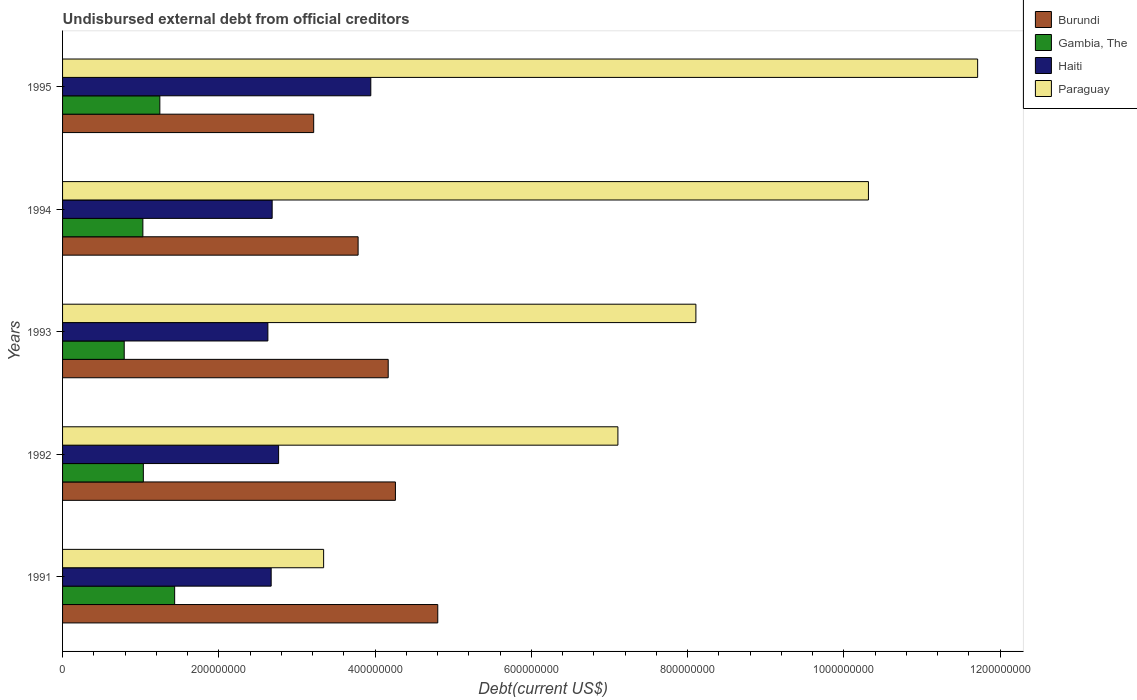How many different coloured bars are there?
Offer a very short reply. 4. Are the number of bars on each tick of the Y-axis equal?
Ensure brevity in your answer.  Yes. What is the label of the 2nd group of bars from the top?
Offer a terse response. 1994. What is the total debt in Gambia, The in 1991?
Provide a succinct answer. 1.43e+08. Across all years, what is the maximum total debt in Burundi?
Keep it short and to the point. 4.80e+08. Across all years, what is the minimum total debt in Gambia, The?
Your answer should be compact. 7.89e+07. What is the total total debt in Paraguay in the graph?
Give a very brief answer. 4.06e+09. What is the difference between the total debt in Haiti in 1991 and that in 1993?
Make the answer very short. 4.21e+06. What is the difference between the total debt in Paraguay in 1993 and the total debt in Burundi in 1994?
Offer a terse response. 4.32e+08. What is the average total debt in Paraguay per year?
Provide a short and direct response. 8.12e+08. In the year 1991, what is the difference between the total debt in Paraguay and total debt in Haiti?
Give a very brief answer. 6.71e+07. In how many years, is the total debt in Burundi greater than 720000000 US$?
Provide a short and direct response. 0. What is the ratio of the total debt in Burundi in 1991 to that in 1992?
Your answer should be compact. 1.13. Is the difference between the total debt in Paraguay in 1993 and 1995 greater than the difference between the total debt in Haiti in 1993 and 1995?
Make the answer very short. No. What is the difference between the highest and the second highest total debt in Paraguay?
Offer a terse response. 1.40e+08. What is the difference between the highest and the lowest total debt in Gambia, The?
Your answer should be compact. 6.46e+07. Is the sum of the total debt in Paraguay in 1991 and 1993 greater than the maximum total debt in Gambia, The across all years?
Offer a very short reply. Yes. What does the 3rd bar from the top in 1992 represents?
Provide a succinct answer. Gambia, The. What does the 4th bar from the bottom in 1991 represents?
Give a very brief answer. Paraguay. Is it the case that in every year, the sum of the total debt in Haiti and total debt in Paraguay is greater than the total debt in Gambia, The?
Provide a succinct answer. Yes. Are the values on the major ticks of X-axis written in scientific E-notation?
Offer a very short reply. No. Does the graph contain any zero values?
Your response must be concise. No. Where does the legend appear in the graph?
Your answer should be very brief. Top right. How are the legend labels stacked?
Provide a succinct answer. Vertical. What is the title of the graph?
Your answer should be very brief. Undisbursed external debt from official creditors. What is the label or title of the X-axis?
Your answer should be very brief. Debt(current US$). What is the label or title of the Y-axis?
Ensure brevity in your answer.  Years. What is the Debt(current US$) in Burundi in 1991?
Give a very brief answer. 4.80e+08. What is the Debt(current US$) of Gambia, The in 1991?
Keep it short and to the point. 1.43e+08. What is the Debt(current US$) in Haiti in 1991?
Offer a very short reply. 2.67e+08. What is the Debt(current US$) in Paraguay in 1991?
Keep it short and to the point. 3.34e+08. What is the Debt(current US$) in Burundi in 1992?
Your answer should be very brief. 4.26e+08. What is the Debt(current US$) of Gambia, The in 1992?
Provide a succinct answer. 1.03e+08. What is the Debt(current US$) in Haiti in 1992?
Your response must be concise. 2.76e+08. What is the Debt(current US$) of Paraguay in 1992?
Keep it short and to the point. 7.11e+08. What is the Debt(current US$) in Burundi in 1993?
Ensure brevity in your answer.  4.17e+08. What is the Debt(current US$) of Gambia, The in 1993?
Ensure brevity in your answer.  7.89e+07. What is the Debt(current US$) in Haiti in 1993?
Keep it short and to the point. 2.63e+08. What is the Debt(current US$) of Paraguay in 1993?
Your answer should be very brief. 8.11e+08. What is the Debt(current US$) in Burundi in 1994?
Offer a very short reply. 3.78e+08. What is the Debt(current US$) in Gambia, The in 1994?
Make the answer very short. 1.03e+08. What is the Debt(current US$) in Haiti in 1994?
Offer a very short reply. 2.68e+08. What is the Debt(current US$) in Paraguay in 1994?
Your answer should be very brief. 1.03e+09. What is the Debt(current US$) of Burundi in 1995?
Offer a terse response. 3.21e+08. What is the Debt(current US$) in Gambia, The in 1995?
Make the answer very short. 1.24e+08. What is the Debt(current US$) of Haiti in 1995?
Your answer should be very brief. 3.94e+08. What is the Debt(current US$) in Paraguay in 1995?
Offer a very short reply. 1.17e+09. Across all years, what is the maximum Debt(current US$) in Burundi?
Ensure brevity in your answer.  4.80e+08. Across all years, what is the maximum Debt(current US$) of Gambia, The?
Offer a terse response. 1.43e+08. Across all years, what is the maximum Debt(current US$) in Haiti?
Offer a very short reply. 3.94e+08. Across all years, what is the maximum Debt(current US$) in Paraguay?
Your response must be concise. 1.17e+09. Across all years, what is the minimum Debt(current US$) of Burundi?
Give a very brief answer. 3.21e+08. Across all years, what is the minimum Debt(current US$) in Gambia, The?
Provide a short and direct response. 7.89e+07. Across all years, what is the minimum Debt(current US$) of Haiti?
Your response must be concise. 2.63e+08. Across all years, what is the minimum Debt(current US$) of Paraguay?
Provide a short and direct response. 3.34e+08. What is the total Debt(current US$) in Burundi in the graph?
Provide a short and direct response. 2.02e+09. What is the total Debt(current US$) of Gambia, The in the graph?
Provide a succinct answer. 5.53e+08. What is the total Debt(current US$) in Haiti in the graph?
Your answer should be very brief. 1.47e+09. What is the total Debt(current US$) of Paraguay in the graph?
Provide a succinct answer. 4.06e+09. What is the difference between the Debt(current US$) in Burundi in 1991 and that in 1992?
Keep it short and to the point. 5.42e+07. What is the difference between the Debt(current US$) in Gambia, The in 1991 and that in 1992?
Your answer should be compact. 4.01e+07. What is the difference between the Debt(current US$) of Haiti in 1991 and that in 1992?
Provide a succinct answer. -9.52e+06. What is the difference between the Debt(current US$) of Paraguay in 1991 and that in 1992?
Provide a short and direct response. -3.77e+08. What is the difference between the Debt(current US$) of Burundi in 1991 and that in 1993?
Offer a very short reply. 6.34e+07. What is the difference between the Debt(current US$) of Gambia, The in 1991 and that in 1993?
Your answer should be very brief. 6.46e+07. What is the difference between the Debt(current US$) in Haiti in 1991 and that in 1993?
Your response must be concise. 4.21e+06. What is the difference between the Debt(current US$) in Paraguay in 1991 and that in 1993?
Keep it short and to the point. -4.76e+08. What is the difference between the Debt(current US$) of Burundi in 1991 and that in 1994?
Keep it short and to the point. 1.02e+08. What is the difference between the Debt(current US$) in Gambia, The in 1991 and that in 1994?
Your response must be concise. 4.07e+07. What is the difference between the Debt(current US$) in Haiti in 1991 and that in 1994?
Offer a very short reply. -1.28e+06. What is the difference between the Debt(current US$) of Paraguay in 1991 and that in 1994?
Offer a terse response. -6.97e+08. What is the difference between the Debt(current US$) in Burundi in 1991 and that in 1995?
Keep it short and to the point. 1.59e+08. What is the difference between the Debt(current US$) in Gambia, The in 1991 and that in 1995?
Keep it short and to the point. 1.90e+07. What is the difference between the Debt(current US$) of Haiti in 1991 and that in 1995?
Give a very brief answer. -1.28e+08. What is the difference between the Debt(current US$) of Paraguay in 1991 and that in 1995?
Your answer should be very brief. -8.37e+08. What is the difference between the Debt(current US$) of Burundi in 1992 and that in 1993?
Give a very brief answer. 9.24e+06. What is the difference between the Debt(current US$) of Gambia, The in 1992 and that in 1993?
Offer a terse response. 2.45e+07. What is the difference between the Debt(current US$) in Haiti in 1992 and that in 1993?
Your answer should be very brief. 1.37e+07. What is the difference between the Debt(current US$) of Paraguay in 1992 and that in 1993?
Offer a very short reply. -9.98e+07. What is the difference between the Debt(current US$) of Burundi in 1992 and that in 1994?
Give a very brief answer. 4.78e+07. What is the difference between the Debt(current US$) in Gambia, The in 1992 and that in 1994?
Offer a very short reply. 5.95e+05. What is the difference between the Debt(current US$) in Haiti in 1992 and that in 1994?
Provide a succinct answer. 8.25e+06. What is the difference between the Debt(current US$) in Paraguay in 1992 and that in 1994?
Your response must be concise. -3.21e+08. What is the difference between the Debt(current US$) of Burundi in 1992 and that in 1995?
Provide a short and direct response. 1.05e+08. What is the difference between the Debt(current US$) in Gambia, The in 1992 and that in 1995?
Keep it short and to the point. -2.11e+07. What is the difference between the Debt(current US$) in Haiti in 1992 and that in 1995?
Provide a succinct answer. -1.18e+08. What is the difference between the Debt(current US$) of Paraguay in 1992 and that in 1995?
Make the answer very short. -4.60e+08. What is the difference between the Debt(current US$) of Burundi in 1993 and that in 1994?
Make the answer very short. 3.85e+07. What is the difference between the Debt(current US$) of Gambia, The in 1993 and that in 1994?
Ensure brevity in your answer.  -2.39e+07. What is the difference between the Debt(current US$) of Haiti in 1993 and that in 1994?
Offer a very short reply. -5.49e+06. What is the difference between the Debt(current US$) of Paraguay in 1993 and that in 1994?
Provide a succinct answer. -2.21e+08. What is the difference between the Debt(current US$) in Burundi in 1993 and that in 1995?
Make the answer very short. 9.54e+07. What is the difference between the Debt(current US$) of Gambia, The in 1993 and that in 1995?
Provide a short and direct response. -4.56e+07. What is the difference between the Debt(current US$) of Haiti in 1993 and that in 1995?
Provide a succinct answer. -1.32e+08. What is the difference between the Debt(current US$) of Paraguay in 1993 and that in 1995?
Your response must be concise. -3.61e+08. What is the difference between the Debt(current US$) in Burundi in 1994 and that in 1995?
Provide a short and direct response. 5.68e+07. What is the difference between the Debt(current US$) in Gambia, The in 1994 and that in 1995?
Ensure brevity in your answer.  -2.17e+07. What is the difference between the Debt(current US$) in Haiti in 1994 and that in 1995?
Your answer should be compact. -1.26e+08. What is the difference between the Debt(current US$) of Paraguay in 1994 and that in 1995?
Make the answer very short. -1.40e+08. What is the difference between the Debt(current US$) in Burundi in 1991 and the Debt(current US$) in Gambia, The in 1992?
Your response must be concise. 3.77e+08. What is the difference between the Debt(current US$) of Burundi in 1991 and the Debt(current US$) of Haiti in 1992?
Your response must be concise. 2.04e+08. What is the difference between the Debt(current US$) in Burundi in 1991 and the Debt(current US$) in Paraguay in 1992?
Provide a short and direct response. -2.31e+08. What is the difference between the Debt(current US$) in Gambia, The in 1991 and the Debt(current US$) in Haiti in 1992?
Make the answer very short. -1.33e+08. What is the difference between the Debt(current US$) of Gambia, The in 1991 and the Debt(current US$) of Paraguay in 1992?
Your answer should be very brief. -5.67e+08. What is the difference between the Debt(current US$) of Haiti in 1991 and the Debt(current US$) of Paraguay in 1992?
Make the answer very short. -4.44e+08. What is the difference between the Debt(current US$) of Burundi in 1991 and the Debt(current US$) of Gambia, The in 1993?
Provide a short and direct response. 4.01e+08. What is the difference between the Debt(current US$) in Burundi in 1991 and the Debt(current US$) in Haiti in 1993?
Keep it short and to the point. 2.17e+08. What is the difference between the Debt(current US$) of Burundi in 1991 and the Debt(current US$) of Paraguay in 1993?
Make the answer very short. -3.30e+08. What is the difference between the Debt(current US$) in Gambia, The in 1991 and the Debt(current US$) in Haiti in 1993?
Your answer should be compact. -1.19e+08. What is the difference between the Debt(current US$) in Gambia, The in 1991 and the Debt(current US$) in Paraguay in 1993?
Your answer should be compact. -6.67e+08. What is the difference between the Debt(current US$) of Haiti in 1991 and the Debt(current US$) of Paraguay in 1993?
Provide a succinct answer. -5.44e+08. What is the difference between the Debt(current US$) of Burundi in 1991 and the Debt(current US$) of Gambia, The in 1994?
Make the answer very short. 3.77e+08. What is the difference between the Debt(current US$) in Burundi in 1991 and the Debt(current US$) in Haiti in 1994?
Your answer should be very brief. 2.12e+08. What is the difference between the Debt(current US$) of Burundi in 1991 and the Debt(current US$) of Paraguay in 1994?
Ensure brevity in your answer.  -5.51e+08. What is the difference between the Debt(current US$) of Gambia, The in 1991 and the Debt(current US$) of Haiti in 1994?
Make the answer very short. -1.25e+08. What is the difference between the Debt(current US$) in Gambia, The in 1991 and the Debt(current US$) in Paraguay in 1994?
Provide a short and direct response. -8.88e+08. What is the difference between the Debt(current US$) in Haiti in 1991 and the Debt(current US$) in Paraguay in 1994?
Your answer should be compact. -7.64e+08. What is the difference between the Debt(current US$) of Burundi in 1991 and the Debt(current US$) of Gambia, The in 1995?
Make the answer very short. 3.56e+08. What is the difference between the Debt(current US$) in Burundi in 1991 and the Debt(current US$) in Haiti in 1995?
Give a very brief answer. 8.57e+07. What is the difference between the Debt(current US$) of Burundi in 1991 and the Debt(current US$) of Paraguay in 1995?
Provide a succinct answer. -6.91e+08. What is the difference between the Debt(current US$) of Gambia, The in 1991 and the Debt(current US$) of Haiti in 1995?
Make the answer very short. -2.51e+08. What is the difference between the Debt(current US$) in Gambia, The in 1991 and the Debt(current US$) in Paraguay in 1995?
Your response must be concise. -1.03e+09. What is the difference between the Debt(current US$) of Haiti in 1991 and the Debt(current US$) of Paraguay in 1995?
Provide a short and direct response. -9.04e+08. What is the difference between the Debt(current US$) in Burundi in 1992 and the Debt(current US$) in Gambia, The in 1993?
Provide a short and direct response. 3.47e+08. What is the difference between the Debt(current US$) in Burundi in 1992 and the Debt(current US$) in Haiti in 1993?
Make the answer very short. 1.63e+08. What is the difference between the Debt(current US$) in Burundi in 1992 and the Debt(current US$) in Paraguay in 1993?
Your response must be concise. -3.85e+08. What is the difference between the Debt(current US$) of Gambia, The in 1992 and the Debt(current US$) of Haiti in 1993?
Provide a short and direct response. -1.59e+08. What is the difference between the Debt(current US$) of Gambia, The in 1992 and the Debt(current US$) of Paraguay in 1993?
Offer a very short reply. -7.07e+08. What is the difference between the Debt(current US$) of Haiti in 1992 and the Debt(current US$) of Paraguay in 1993?
Ensure brevity in your answer.  -5.34e+08. What is the difference between the Debt(current US$) of Burundi in 1992 and the Debt(current US$) of Gambia, The in 1994?
Make the answer very short. 3.23e+08. What is the difference between the Debt(current US$) of Burundi in 1992 and the Debt(current US$) of Haiti in 1994?
Your answer should be very brief. 1.58e+08. What is the difference between the Debt(current US$) of Burundi in 1992 and the Debt(current US$) of Paraguay in 1994?
Your answer should be compact. -6.05e+08. What is the difference between the Debt(current US$) in Gambia, The in 1992 and the Debt(current US$) in Haiti in 1994?
Ensure brevity in your answer.  -1.65e+08. What is the difference between the Debt(current US$) of Gambia, The in 1992 and the Debt(current US$) of Paraguay in 1994?
Your answer should be compact. -9.28e+08. What is the difference between the Debt(current US$) in Haiti in 1992 and the Debt(current US$) in Paraguay in 1994?
Make the answer very short. -7.55e+08. What is the difference between the Debt(current US$) of Burundi in 1992 and the Debt(current US$) of Gambia, The in 1995?
Your answer should be very brief. 3.02e+08. What is the difference between the Debt(current US$) in Burundi in 1992 and the Debt(current US$) in Haiti in 1995?
Offer a terse response. 3.15e+07. What is the difference between the Debt(current US$) in Burundi in 1992 and the Debt(current US$) in Paraguay in 1995?
Keep it short and to the point. -7.45e+08. What is the difference between the Debt(current US$) of Gambia, The in 1992 and the Debt(current US$) of Haiti in 1995?
Offer a terse response. -2.91e+08. What is the difference between the Debt(current US$) in Gambia, The in 1992 and the Debt(current US$) in Paraguay in 1995?
Offer a very short reply. -1.07e+09. What is the difference between the Debt(current US$) of Haiti in 1992 and the Debt(current US$) of Paraguay in 1995?
Keep it short and to the point. -8.95e+08. What is the difference between the Debt(current US$) in Burundi in 1993 and the Debt(current US$) in Gambia, The in 1994?
Keep it short and to the point. 3.14e+08. What is the difference between the Debt(current US$) of Burundi in 1993 and the Debt(current US$) of Haiti in 1994?
Provide a succinct answer. 1.49e+08. What is the difference between the Debt(current US$) in Burundi in 1993 and the Debt(current US$) in Paraguay in 1994?
Ensure brevity in your answer.  -6.15e+08. What is the difference between the Debt(current US$) in Gambia, The in 1993 and the Debt(current US$) in Haiti in 1994?
Ensure brevity in your answer.  -1.89e+08. What is the difference between the Debt(current US$) of Gambia, The in 1993 and the Debt(current US$) of Paraguay in 1994?
Offer a terse response. -9.52e+08. What is the difference between the Debt(current US$) of Haiti in 1993 and the Debt(current US$) of Paraguay in 1994?
Offer a very short reply. -7.69e+08. What is the difference between the Debt(current US$) of Burundi in 1993 and the Debt(current US$) of Gambia, The in 1995?
Your answer should be compact. 2.92e+08. What is the difference between the Debt(current US$) of Burundi in 1993 and the Debt(current US$) of Haiti in 1995?
Make the answer very short. 2.23e+07. What is the difference between the Debt(current US$) of Burundi in 1993 and the Debt(current US$) of Paraguay in 1995?
Ensure brevity in your answer.  -7.54e+08. What is the difference between the Debt(current US$) of Gambia, The in 1993 and the Debt(current US$) of Haiti in 1995?
Ensure brevity in your answer.  -3.16e+08. What is the difference between the Debt(current US$) in Gambia, The in 1993 and the Debt(current US$) in Paraguay in 1995?
Your answer should be compact. -1.09e+09. What is the difference between the Debt(current US$) in Haiti in 1993 and the Debt(current US$) in Paraguay in 1995?
Provide a short and direct response. -9.08e+08. What is the difference between the Debt(current US$) in Burundi in 1994 and the Debt(current US$) in Gambia, The in 1995?
Offer a terse response. 2.54e+08. What is the difference between the Debt(current US$) in Burundi in 1994 and the Debt(current US$) in Haiti in 1995?
Offer a terse response. -1.62e+07. What is the difference between the Debt(current US$) in Burundi in 1994 and the Debt(current US$) in Paraguay in 1995?
Make the answer very short. -7.93e+08. What is the difference between the Debt(current US$) in Gambia, The in 1994 and the Debt(current US$) in Haiti in 1995?
Offer a very short reply. -2.92e+08. What is the difference between the Debt(current US$) in Gambia, The in 1994 and the Debt(current US$) in Paraguay in 1995?
Offer a very short reply. -1.07e+09. What is the difference between the Debt(current US$) of Haiti in 1994 and the Debt(current US$) of Paraguay in 1995?
Give a very brief answer. -9.03e+08. What is the average Debt(current US$) in Burundi per year?
Your answer should be very brief. 4.05e+08. What is the average Debt(current US$) in Gambia, The per year?
Give a very brief answer. 1.11e+08. What is the average Debt(current US$) of Haiti per year?
Keep it short and to the point. 2.94e+08. What is the average Debt(current US$) of Paraguay per year?
Your response must be concise. 8.12e+08. In the year 1991, what is the difference between the Debt(current US$) of Burundi and Debt(current US$) of Gambia, The?
Provide a short and direct response. 3.37e+08. In the year 1991, what is the difference between the Debt(current US$) in Burundi and Debt(current US$) in Haiti?
Offer a terse response. 2.13e+08. In the year 1991, what is the difference between the Debt(current US$) in Burundi and Debt(current US$) in Paraguay?
Your answer should be very brief. 1.46e+08. In the year 1991, what is the difference between the Debt(current US$) of Gambia, The and Debt(current US$) of Haiti?
Provide a short and direct response. -1.24e+08. In the year 1991, what is the difference between the Debt(current US$) in Gambia, The and Debt(current US$) in Paraguay?
Keep it short and to the point. -1.91e+08. In the year 1991, what is the difference between the Debt(current US$) of Haiti and Debt(current US$) of Paraguay?
Keep it short and to the point. -6.71e+07. In the year 1992, what is the difference between the Debt(current US$) in Burundi and Debt(current US$) in Gambia, The?
Provide a short and direct response. 3.23e+08. In the year 1992, what is the difference between the Debt(current US$) in Burundi and Debt(current US$) in Haiti?
Provide a short and direct response. 1.50e+08. In the year 1992, what is the difference between the Debt(current US$) in Burundi and Debt(current US$) in Paraguay?
Your response must be concise. -2.85e+08. In the year 1992, what is the difference between the Debt(current US$) in Gambia, The and Debt(current US$) in Haiti?
Offer a very short reply. -1.73e+08. In the year 1992, what is the difference between the Debt(current US$) of Gambia, The and Debt(current US$) of Paraguay?
Ensure brevity in your answer.  -6.07e+08. In the year 1992, what is the difference between the Debt(current US$) in Haiti and Debt(current US$) in Paraguay?
Offer a very short reply. -4.34e+08. In the year 1993, what is the difference between the Debt(current US$) in Burundi and Debt(current US$) in Gambia, The?
Your answer should be compact. 3.38e+08. In the year 1993, what is the difference between the Debt(current US$) in Burundi and Debt(current US$) in Haiti?
Give a very brief answer. 1.54e+08. In the year 1993, what is the difference between the Debt(current US$) of Burundi and Debt(current US$) of Paraguay?
Provide a succinct answer. -3.94e+08. In the year 1993, what is the difference between the Debt(current US$) of Gambia, The and Debt(current US$) of Haiti?
Provide a short and direct response. -1.84e+08. In the year 1993, what is the difference between the Debt(current US$) in Gambia, The and Debt(current US$) in Paraguay?
Keep it short and to the point. -7.32e+08. In the year 1993, what is the difference between the Debt(current US$) of Haiti and Debt(current US$) of Paraguay?
Make the answer very short. -5.48e+08. In the year 1994, what is the difference between the Debt(current US$) of Burundi and Debt(current US$) of Gambia, The?
Ensure brevity in your answer.  2.75e+08. In the year 1994, what is the difference between the Debt(current US$) in Burundi and Debt(current US$) in Haiti?
Keep it short and to the point. 1.10e+08. In the year 1994, what is the difference between the Debt(current US$) in Burundi and Debt(current US$) in Paraguay?
Provide a succinct answer. -6.53e+08. In the year 1994, what is the difference between the Debt(current US$) of Gambia, The and Debt(current US$) of Haiti?
Keep it short and to the point. -1.65e+08. In the year 1994, what is the difference between the Debt(current US$) in Gambia, The and Debt(current US$) in Paraguay?
Your answer should be very brief. -9.29e+08. In the year 1994, what is the difference between the Debt(current US$) of Haiti and Debt(current US$) of Paraguay?
Your response must be concise. -7.63e+08. In the year 1995, what is the difference between the Debt(current US$) of Burundi and Debt(current US$) of Gambia, The?
Ensure brevity in your answer.  1.97e+08. In the year 1995, what is the difference between the Debt(current US$) of Burundi and Debt(current US$) of Haiti?
Provide a succinct answer. -7.31e+07. In the year 1995, what is the difference between the Debt(current US$) in Burundi and Debt(current US$) in Paraguay?
Offer a terse response. -8.50e+08. In the year 1995, what is the difference between the Debt(current US$) of Gambia, The and Debt(current US$) of Haiti?
Ensure brevity in your answer.  -2.70e+08. In the year 1995, what is the difference between the Debt(current US$) of Gambia, The and Debt(current US$) of Paraguay?
Your response must be concise. -1.05e+09. In the year 1995, what is the difference between the Debt(current US$) of Haiti and Debt(current US$) of Paraguay?
Your response must be concise. -7.77e+08. What is the ratio of the Debt(current US$) in Burundi in 1991 to that in 1992?
Provide a short and direct response. 1.13. What is the ratio of the Debt(current US$) of Gambia, The in 1991 to that in 1992?
Make the answer very short. 1.39. What is the ratio of the Debt(current US$) of Haiti in 1991 to that in 1992?
Ensure brevity in your answer.  0.97. What is the ratio of the Debt(current US$) of Paraguay in 1991 to that in 1992?
Your response must be concise. 0.47. What is the ratio of the Debt(current US$) in Burundi in 1991 to that in 1993?
Your answer should be very brief. 1.15. What is the ratio of the Debt(current US$) in Gambia, The in 1991 to that in 1993?
Provide a succinct answer. 1.82. What is the ratio of the Debt(current US$) in Paraguay in 1991 to that in 1993?
Provide a short and direct response. 0.41. What is the ratio of the Debt(current US$) of Burundi in 1991 to that in 1994?
Keep it short and to the point. 1.27. What is the ratio of the Debt(current US$) in Gambia, The in 1991 to that in 1994?
Keep it short and to the point. 1.4. What is the ratio of the Debt(current US$) of Haiti in 1991 to that in 1994?
Offer a very short reply. 1. What is the ratio of the Debt(current US$) of Paraguay in 1991 to that in 1994?
Offer a terse response. 0.32. What is the ratio of the Debt(current US$) of Burundi in 1991 to that in 1995?
Make the answer very short. 1.49. What is the ratio of the Debt(current US$) of Gambia, The in 1991 to that in 1995?
Give a very brief answer. 1.15. What is the ratio of the Debt(current US$) of Haiti in 1991 to that in 1995?
Provide a short and direct response. 0.68. What is the ratio of the Debt(current US$) of Paraguay in 1991 to that in 1995?
Provide a short and direct response. 0.29. What is the ratio of the Debt(current US$) in Burundi in 1992 to that in 1993?
Make the answer very short. 1.02. What is the ratio of the Debt(current US$) in Gambia, The in 1992 to that in 1993?
Provide a short and direct response. 1.31. What is the ratio of the Debt(current US$) of Haiti in 1992 to that in 1993?
Your answer should be compact. 1.05. What is the ratio of the Debt(current US$) in Paraguay in 1992 to that in 1993?
Your response must be concise. 0.88. What is the ratio of the Debt(current US$) in Burundi in 1992 to that in 1994?
Ensure brevity in your answer.  1.13. What is the ratio of the Debt(current US$) in Haiti in 1992 to that in 1994?
Offer a very short reply. 1.03. What is the ratio of the Debt(current US$) in Paraguay in 1992 to that in 1994?
Provide a short and direct response. 0.69. What is the ratio of the Debt(current US$) of Burundi in 1992 to that in 1995?
Offer a terse response. 1.33. What is the ratio of the Debt(current US$) in Gambia, The in 1992 to that in 1995?
Ensure brevity in your answer.  0.83. What is the ratio of the Debt(current US$) of Haiti in 1992 to that in 1995?
Provide a succinct answer. 0.7. What is the ratio of the Debt(current US$) in Paraguay in 1992 to that in 1995?
Keep it short and to the point. 0.61. What is the ratio of the Debt(current US$) of Burundi in 1993 to that in 1994?
Ensure brevity in your answer.  1.1. What is the ratio of the Debt(current US$) in Gambia, The in 1993 to that in 1994?
Offer a very short reply. 0.77. What is the ratio of the Debt(current US$) in Haiti in 1993 to that in 1994?
Your answer should be compact. 0.98. What is the ratio of the Debt(current US$) of Paraguay in 1993 to that in 1994?
Your answer should be very brief. 0.79. What is the ratio of the Debt(current US$) in Burundi in 1993 to that in 1995?
Your answer should be compact. 1.3. What is the ratio of the Debt(current US$) of Gambia, The in 1993 to that in 1995?
Your answer should be compact. 0.63. What is the ratio of the Debt(current US$) in Haiti in 1993 to that in 1995?
Make the answer very short. 0.67. What is the ratio of the Debt(current US$) in Paraguay in 1993 to that in 1995?
Your response must be concise. 0.69. What is the ratio of the Debt(current US$) in Burundi in 1994 to that in 1995?
Your answer should be compact. 1.18. What is the ratio of the Debt(current US$) in Gambia, The in 1994 to that in 1995?
Offer a very short reply. 0.83. What is the ratio of the Debt(current US$) in Haiti in 1994 to that in 1995?
Make the answer very short. 0.68. What is the ratio of the Debt(current US$) in Paraguay in 1994 to that in 1995?
Give a very brief answer. 0.88. What is the difference between the highest and the second highest Debt(current US$) in Burundi?
Your answer should be compact. 5.42e+07. What is the difference between the highest and the second highest Debt(current US$) in Gambia, The?
Offer a terse response. 1.90e+07. What is the difference between the highest and the second highest Debt(current US$) of Haiti?
Your answer should be very brief. 1.18e+08. What is the difference between the highest and the second highest Debt(current US$) of Paraguay?
Make the answer very short. 1.40e+08. What is the difference between the highest and the lowest Debt(current US$) in Burundi?
Keep it short and to the point. 1.59e+08. What is the difference between the highest and the lowest Debt(current US$) in Gambia, The?
Provide a short and direct response. 6.46e+07. What is the difference between the highest and the lowest Debt(current US$) of Haiti?
Ensure brevity in your answer.  1.32e+08. What is the difference between the highest and the lowest Debt(current US$) of Paraguay?
Provide a succinct answer. 8.37e+08. 